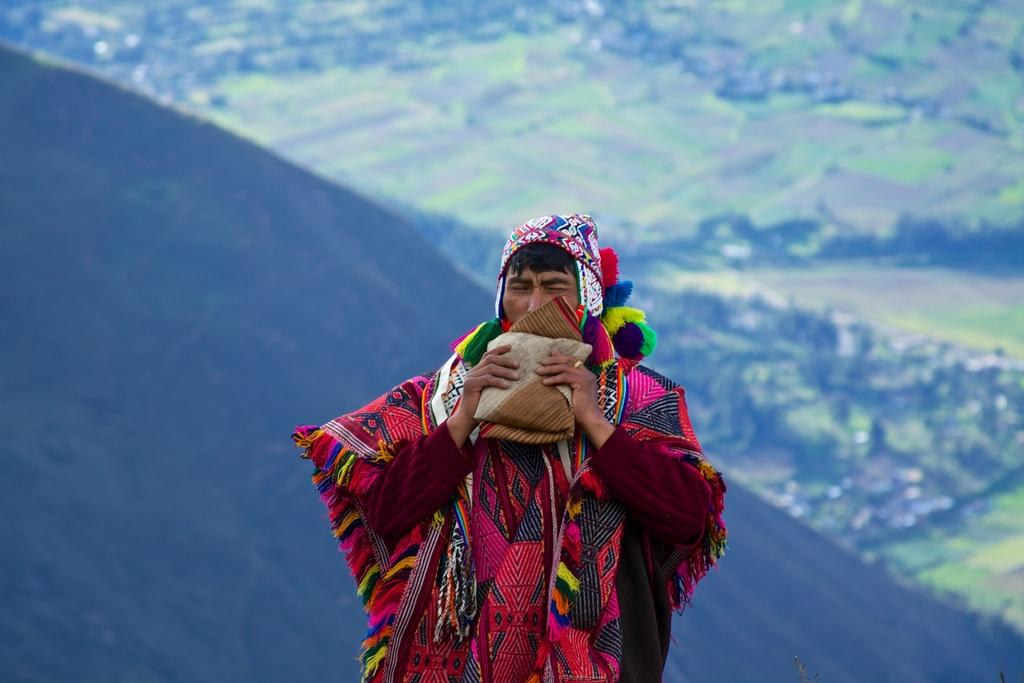What is the main subject of the image? There is a person standing in the image. What is the person doing in the image? The person is carrying an object. What type of landscape can be seen in the image? Mountains and fields are visible in the image. Can you describe any other elements in the image? There are some other unspecified elements in the image. How many brothers does the person in the image have? There is no information about the person's brothers in the image. What type of apple is being used as a prop in the image? There is no apple present in the image. 